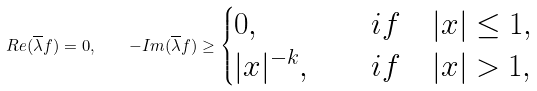<formula> <loc_0><loc_0><loc_500><loc_500>R e ( \overline { \lambda } f ) = 0 , \quad - I m ( \overline { \lambda } f ) \geq \begin{cases} 0 , & \quad i f \quad | x | \leq 1 , \\ | x | ^ { - k } , & \quad i f \quad | x | > 1 , \end{cases}</formula> 